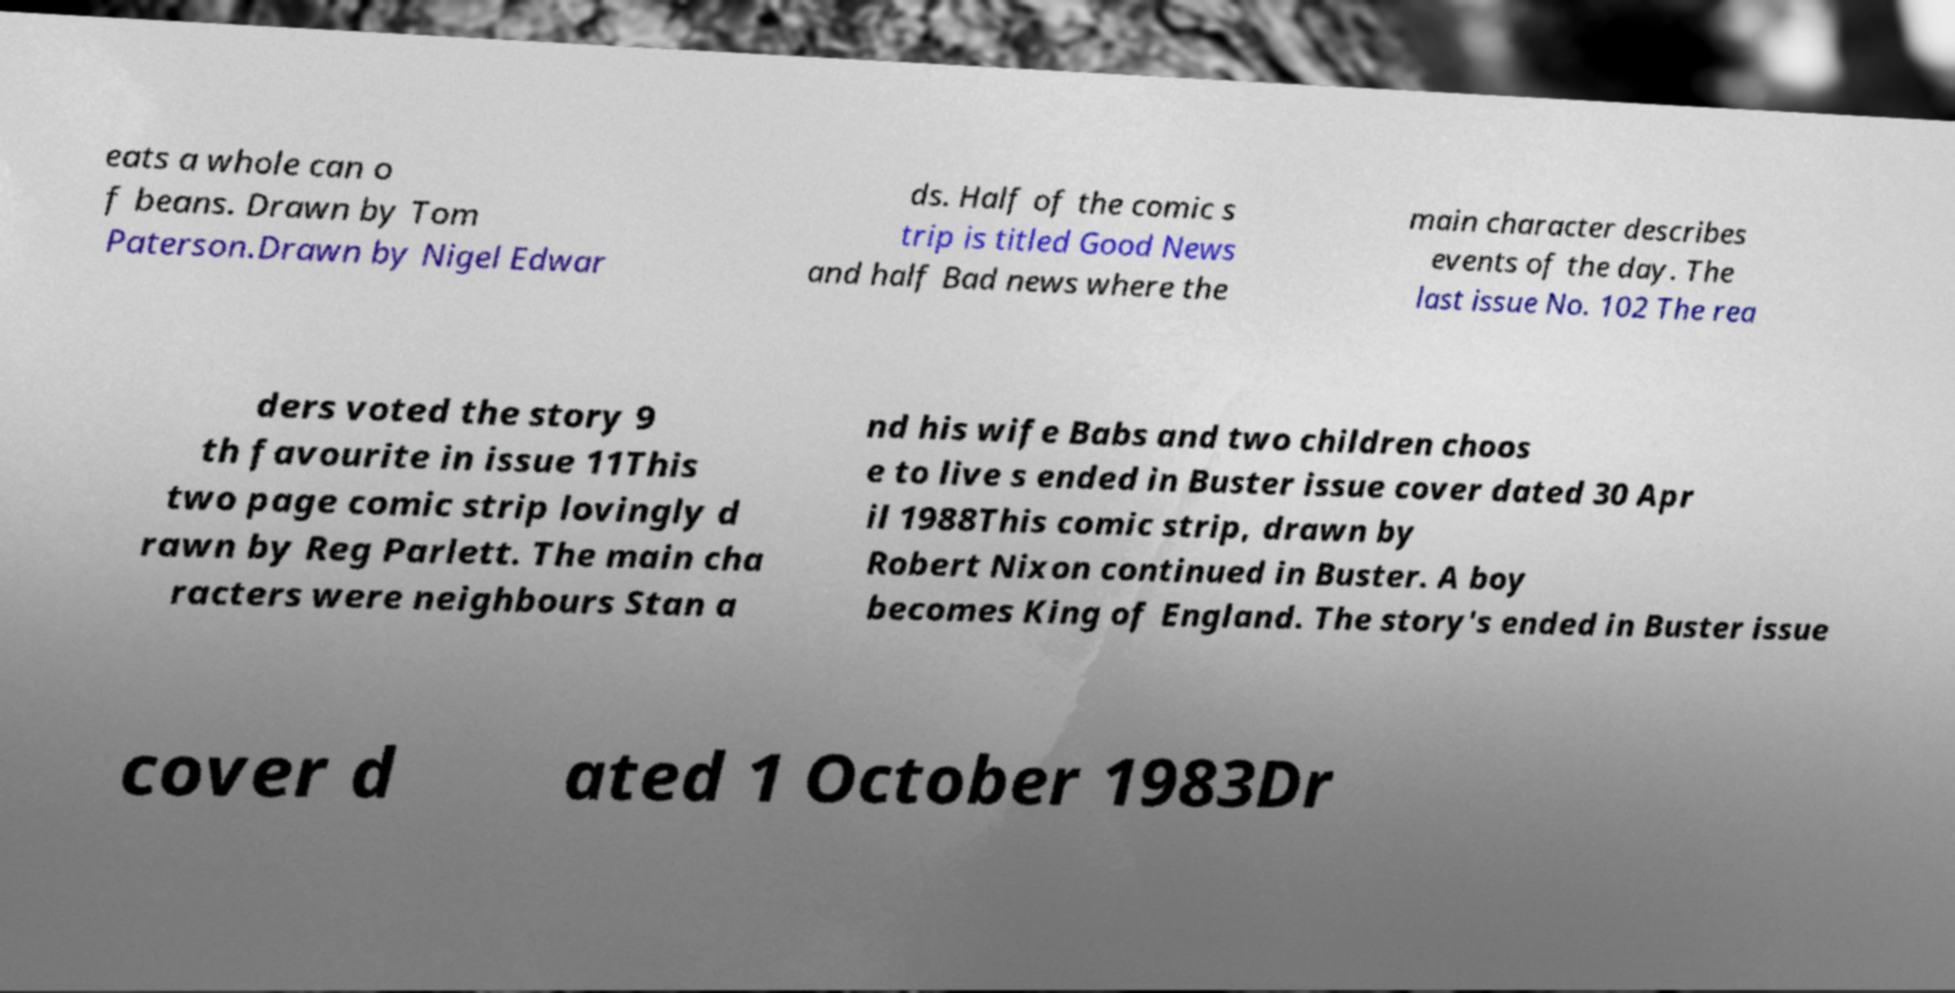For documentation purposes, I need the text within this image transcribed. Could you provide that? eats a whole can o f beans. Drawn by Tom Paterson.Drawn by Nigel Edwar ds. Half of the comic s trip is titled Good News and half Bad news where the main character describes events of the day. The last issue No. 102 The rea ders voted the story 9 th favourite in issue 11This two page comic strip lovingly d rawn by Reg Parlett. The main cha racters were neighbours Stan a nd his wife Babs and two children choos e to live s ended in Buster issue cover dated 30 Apr il 1988This comic strip, drawn by Robert Nixon continued in Buster. A boy becomes King of England. The story's ended in Buster issue cover d ated 1 October 1983Dr 